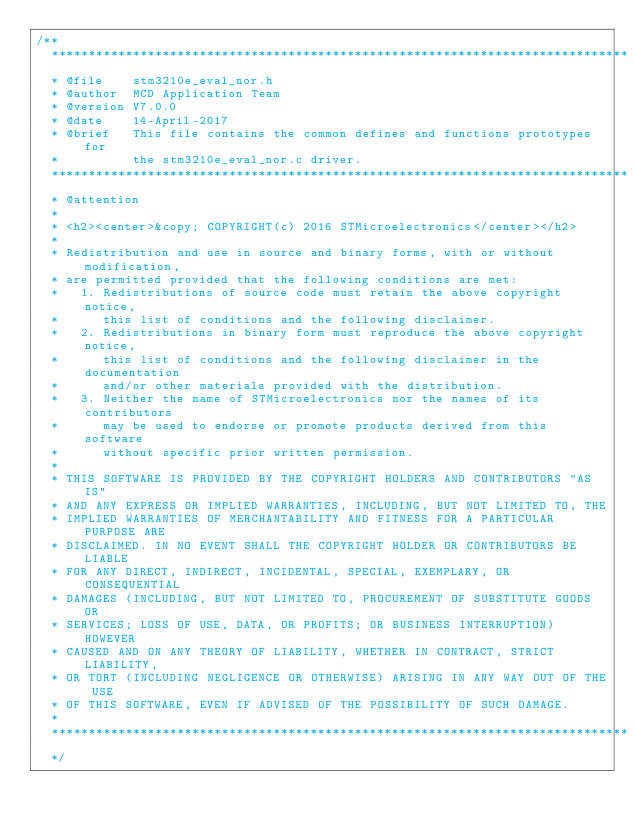<code> <loc_0><loc_0><loc_500><loc_500><_C_>/**
  ******************************************************************************
  * @file    stm3210e_eval_nor.h
  * @author  MCD Application Team
  * @version V7.0.0
  * @date    14-April-2017
  * @brief   This file contains the common defines and functions prototypes for
  *          the stm3210e_eval_nor.c driver.
  ******************************************************************************
  * @attention
  *
  * <h2><center>&copy; COPYRIGHT(c) 2016 STMicroelectronics</center></h2>
  *
  * Redistribution and use in source and binary forms, with or without modification,
  * are permitted provided that the following conditions are met:
  *   1. Redistributions of source code must retain the above copyright notice,
  *      this list of conditions and the following disclaimer.
  *   2. Redistributions in binary form must reproduce the above copyright notice,
  *      this list of conditions and the following disclaimer in the documentation
  *      and/or other materials provided with the distribution.
  *   3. Neither the name of STMicroelectronics nor the names of its contributors
  *      may be used to endorse or promote products derived from this software
  *      without specific prior written permission.
  *
  * THIS SOFTWARE IS PROVIDED BY THE COPYRIGHT HOLDERS AND CONTRIBUTORS "AS IS"
  * AND ANY EXPRESS OR IMPLIED WARRANTIES, INCLUDING, BUT NOT LIMITED TO, THE
  * IMPLIED WARRANTIES OF MERCHANTABILITY AND FITNESS FOR A PARTICULAR PURPOSE ARE
  * DISCLAIMED. IN NO EVENT SHALL THE COPYRIGHT HOLDER OR CONTRIBUTORS BE LIABLE
  * FOR ANY DIRECT, INDIRECT, INCIDENTAL, SPECIAL, EXEMPLARY, OR CONSEQUENTIAL
  * DAMAGES (INCLUDING, BUT NOT LIMITED TO, PROCUREMENT OF SUBSTITUTE GOODS OR
  * SERVICES; LOSS OF USE, DATA, OR PROFITS; OR BUSINESS INTERRUPTION) HOWEVER
  * CAUSED AND ON ANY THEORY OF LIABILITY, WHETHER IN CONTRACT, STRICT LIABILITY,
  * OR TORT (INCLUDING NEGLIGENCE OR OTHERWISE) ARISING IN ANY WAY OUT OF THE USE
  * OF THIS SOFTWARE, EVEN IF ADVISED OF THE POSSIBILITY OF SUCH DAMAGE.
  *
  ******************************************************************************
  */ 
</code> 